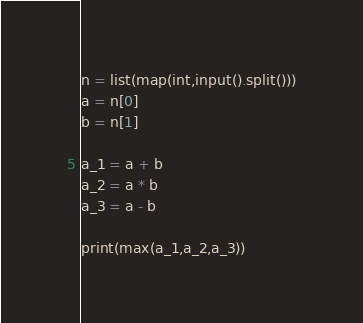Convert code to text. <code><loc_0><loc_0><loc_500><loc_500><_Python_>n = list(map(int,input().split()))
a = n[0]
b = n[1]

a_1 = a + b
a_2 = a * b
a_3 = a - b

print(max(a_1,a_2,a_3))</code> 